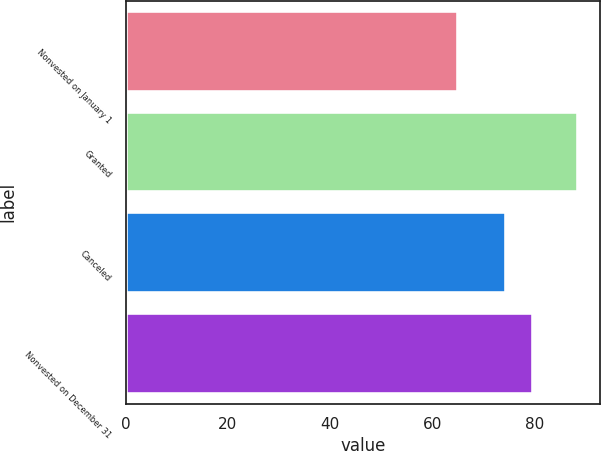Convert chart. <chart><loc_0><loc_0><loc_500><loc_500><bar_chart><fcel>Nonvested on January 1<fcel>Granted<fcel>Canceled<fcel>Nonvested on December 31<nl><fcel>65.04<fcel>88.47<fcel>74.35<fcel>79.71<nl></chart> 